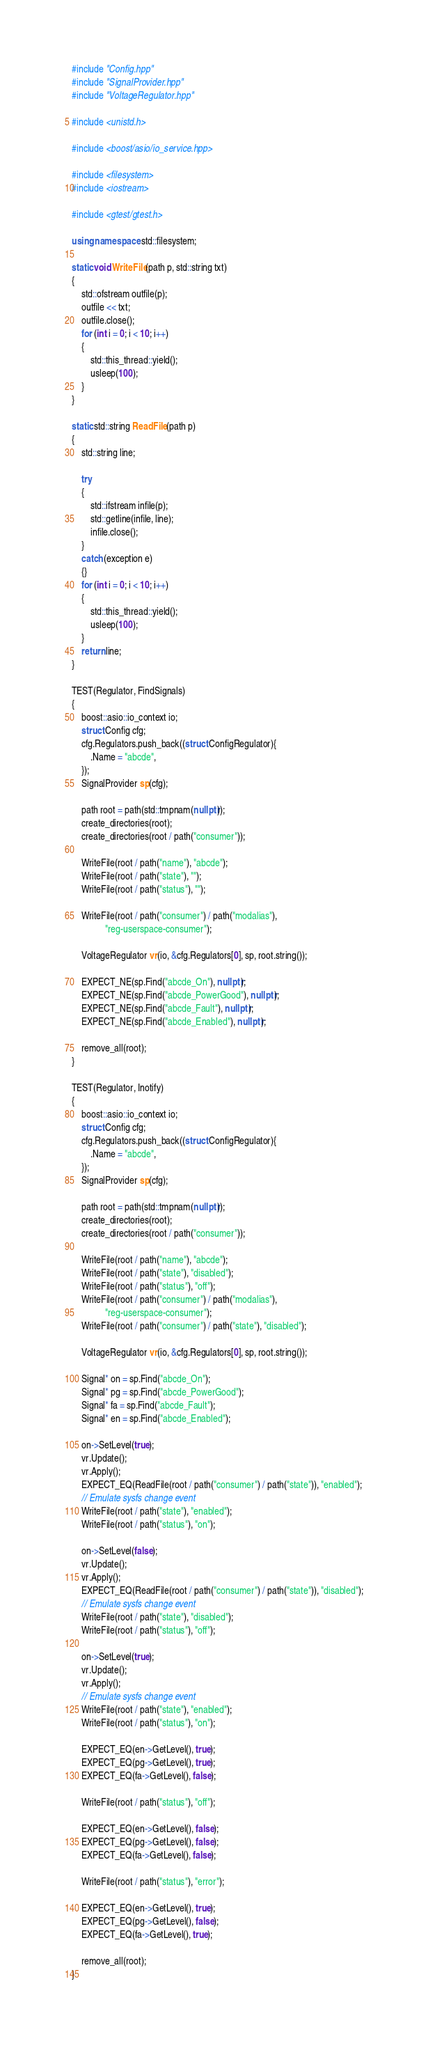Convert code to text. <code><loc_0><loc_0><loc_500><loc_500><_C++_>#include "Config.hpp"
#include "SignalProvider.hpp"
#include "VoltageRegulator.hpp"

#include <unistd.h>

#include <boost/asio/io_service.hpp>

#include <filesystem>
#include <iostream>

#include <gtest/gtest.h>

using namespace std::filesystem;

static void WriteFile(path p, std::string txt)
{
    std::ofstream outfile(p);
    outfile << txt;
    outfile.close();
    for (int i = 0; i < 10; i++)
    {
        std::this_thread::yield();
        usleep(100);
    }
}

static std::string ReadFile(path p)
{
    std::string line;

    try
    {
        std::ifstream infile(p);
        std::getline(infile, line);
        infile.close();
    }
    catch (exception e)
    {}
    for (int i = 0; i < 10; i++)
    {
        std::this_thread::yield();
        usleep(100);
    }
    return line;
}

TEST(Regulator, FindSignals)
{
    boost::asio::io_context io;
    struct Config cfg;
    cfg.Regulators.push_back((struct ConfigRegulator){
        .Name = "abcde",
    });
    SignalProvider sp(cfg);

    path root = path(std::tmpnam(nullptr));
    create_directories(root);
    create_directories(root / path("consumer"));

    WriteFile(root / path("name"), "abcde");
    WriteFile(root / path("state"), "");
    WriteFile(root / path("status"), "");

    WriteFile(root / path("consumer") / path("modalias"),
              "reg-userspace-consumer");

    VoltageRegulator vr(io, &cfg.Regulators[0], sp, root.string());

    EXPECT_NE(sp.Find("abcde_On"), nullptr);
    EXPECT_NE(sp.Find("abcde_PowerGood"), nullptr);
    EXPECT_NE(sp.Find("abcde_Fault"), nullptr);
    EXPECT_NE(sp.Find("abcde_Enabled"), nullptr);

    remove_all(root);
}

TEST(Regulator, Inotify)
{
    boost::asio::io_context io;
    struct Config cfg;
    cfg.Regulators.push_back((struct ConfigRegulator){
        .Name = "abcde",
    });
    SignalProvider sp(cfg);

    path root = path(std::tmpnam(nullptr));
    create_directories(root);
    create_directories(root / path("consumer"));

    WriteFile(root / path("name"), "abcde");
    WriteFile(root / path("state"), "disabled");
    WriteFile(root / path("status"), "off");
    WriteFile(root / path("consumer") / path("modalias"),
              "reg-userspace-consumer");
    WriteFile(root / path("consumer") / path("state"), "disabled");

    VoltageRegulator vr(io, &cfg.Regulators[0], sp, root.string());

    Signal* on = sp.Find("abcde_On");
    Signal* pg = sp.Find("abcde_PowerGood");
    Signal* fa = sp.Find("abcde_Fault");
    Signal* en = sp.Find("abcde_Enabled");

    on->SetLevel(true);
    vr.Update();
    vr.Apply();
    EXPECT_EQ(ReadFile(root / path("consumer") / path("state")), "enabled");
    // Emulate sysfs change event
    WriteFile(root / path("state"), "enabled");
    WriteFile(root / path("status"), "on");

    on->SetLevel(false);
    vr.Update();
    vr.Apply();
    EXPECT_EQ(ReadFile(root / path("consumer") / path("state")), "disabled");
    // Emulate sysfs change event
    WriteFile(root / path("state"), "disabled");
    WriteFile(root / path("status"), "off");

    on->SetLevel(true);
    vr.Update();
    vr.Apply();
    // Emulate sysfs change event
    WriteFile(root / path("state"), "enabled");
    WriteFile(root / path("status"), "on");

    EXPECT_EQ(en->GetLevel(), true);
    EXPECT_EQ(pg->GetLevel(), true);
    EXPECT_EQ(fa->GetLevel(), false);

    WriteFile(root / path("status"), "off");

    EXPECT_EQ(en->GetLevel(), false);
    EXPECT_EQ(pg->GetLevel(), false);
    EXPECT_EQ(fa->GetLevel(), false);

    WriteFile(root / path("status"), "error");

    EXPECT_EQ(en->GetLevel(), true);
    EXPECT_EQ(pg->GetLevel(), false);
    EXPECT_EQ(fa->GetLevel(), true);

    remove_all(root);
}
</code> 